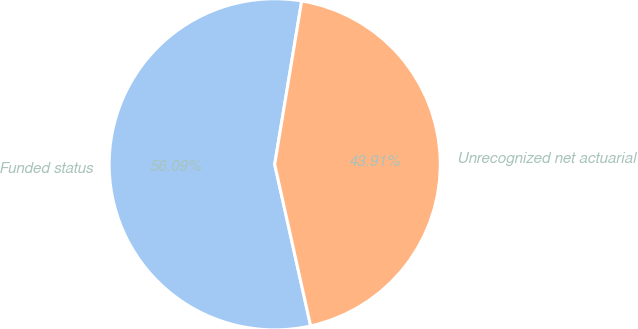<chart> <loc_0><loc_0><loc_500><loc_500><pie_chart><fcel>Funded status<fcel>Unrecognized net actuarial<nl><fcel>56.09%<fcel>43.91%<nl></chart> 